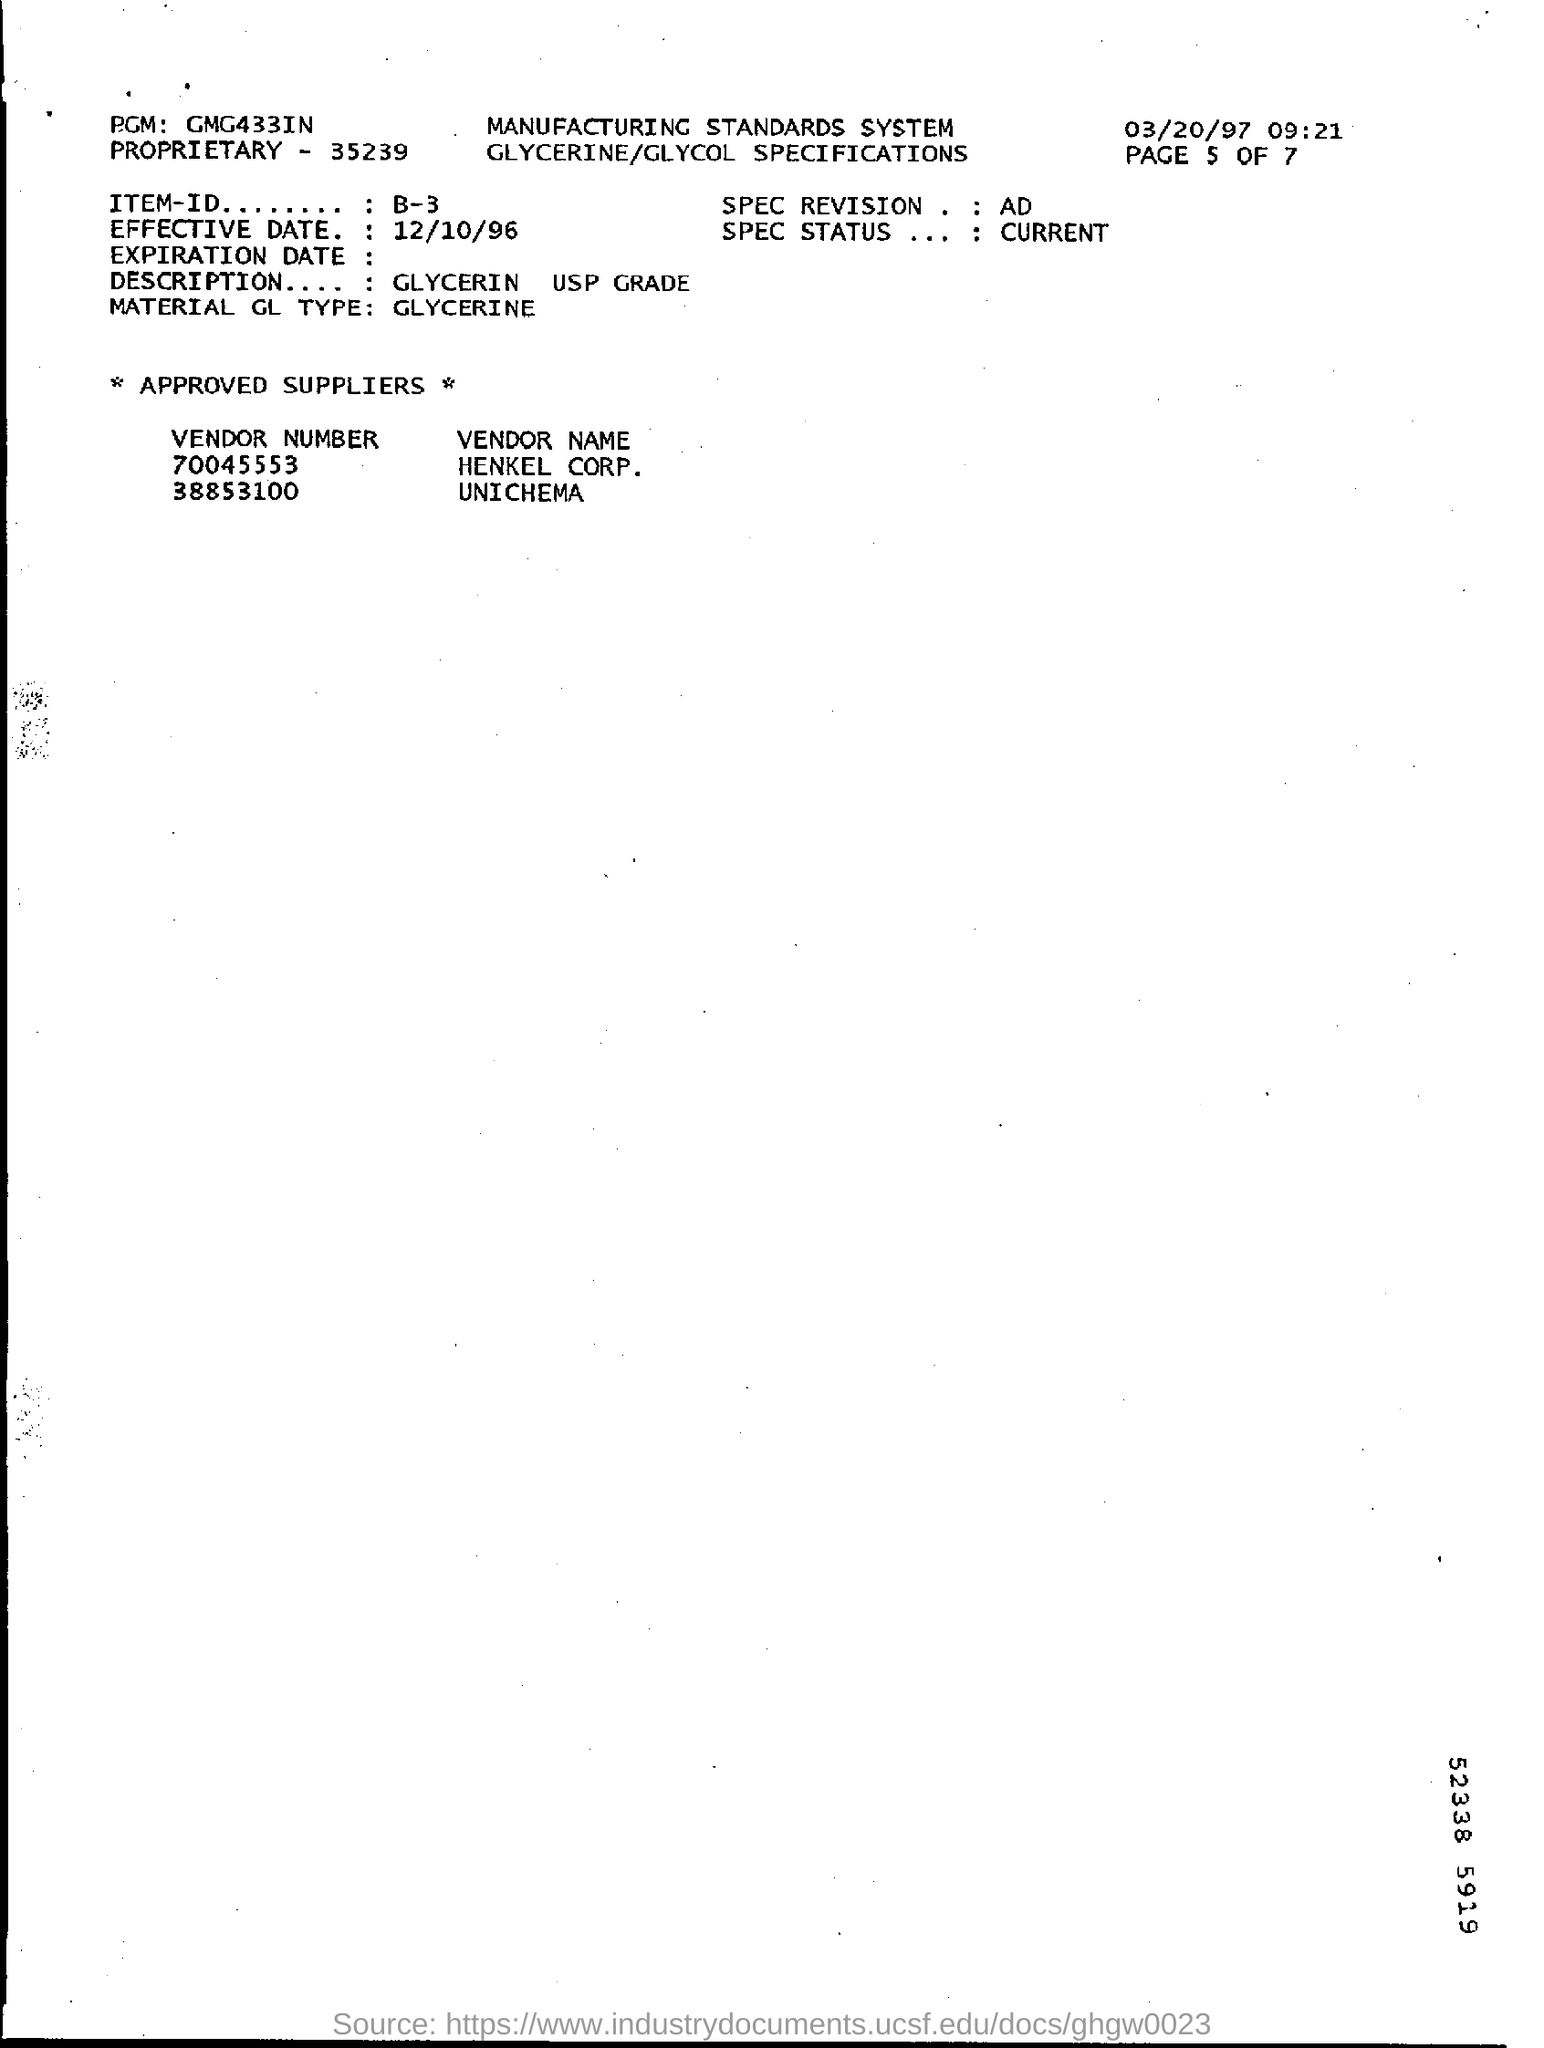Give some essential details in this illustration. The material in question is identified as GL Type, specifically GLYCERINE. Item-ID Number B-3 is what. The effective date of the document is October 12, 1996. 